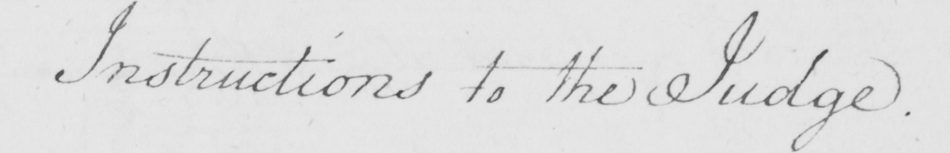Can you tell me what this handwritten text says? Instructions to the Judge . 